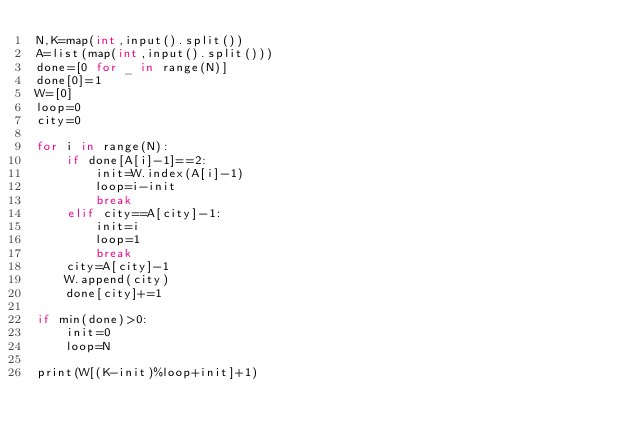Convert code to text. <code><loc_0><loc_0><loc_500><loc_500><_Cython_>N,K=map(int,input().split())
A=list(map(int,input().split()))
done=[0 for _ in range(N)]
done[0]=1
W=[0]
loop=0
city=0

for i in range(N):
    if done[A[i]-1]==2:
        init=W.index(A[i]-1)
        loop=i-init
        break
    elif city==A[city]-1:
        init=i
        loop=1
        break
    city=A[city]-1
    W.append(city)
    done[city]+=1

if min(done)>0:
    init=0
    loop=N

print(W[(K-init)%loop+init]+1)</code> 